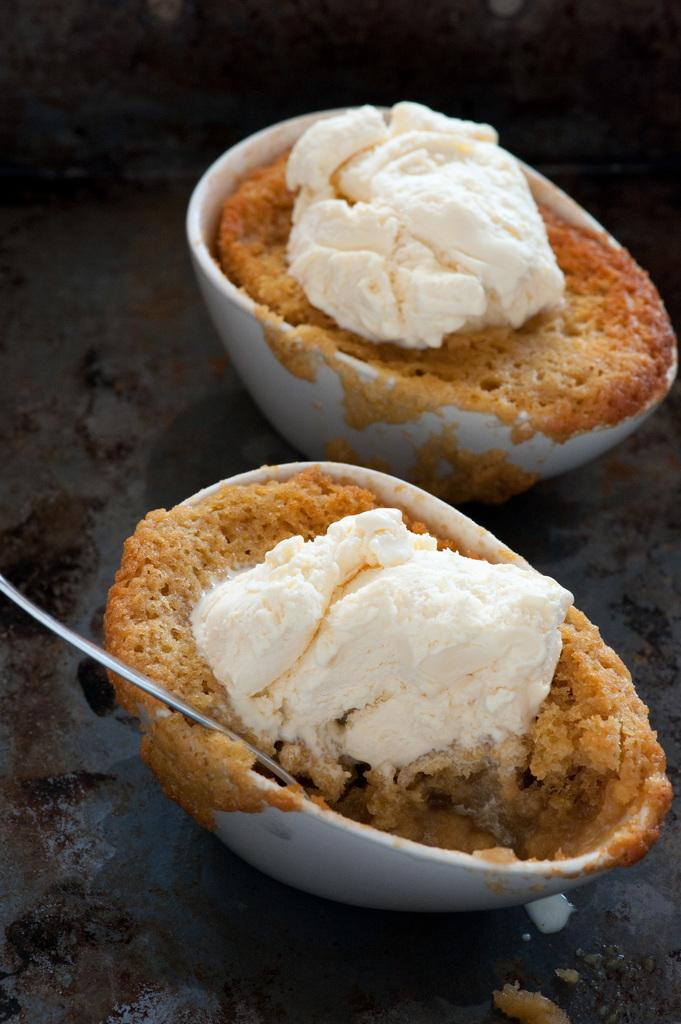What type of food can be seen in the image? The food in the image is in bowls. How are the bowls arranged in the image? The bowls are on a platform. What utensils are present in the image? There are spoons in the image. What type of root can be seen growing in the middle of the image? There is no root present in the image. 